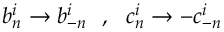<formula> <loc_0><loc_0><loc_500><loc_500>b _ { n } ^ { i } \rightarrow b _ { - n } ^ { i } \ \ , \ \ c _ { n } ^ { i } \rightarrow - c _ { - n } ^ { i }</formula> 